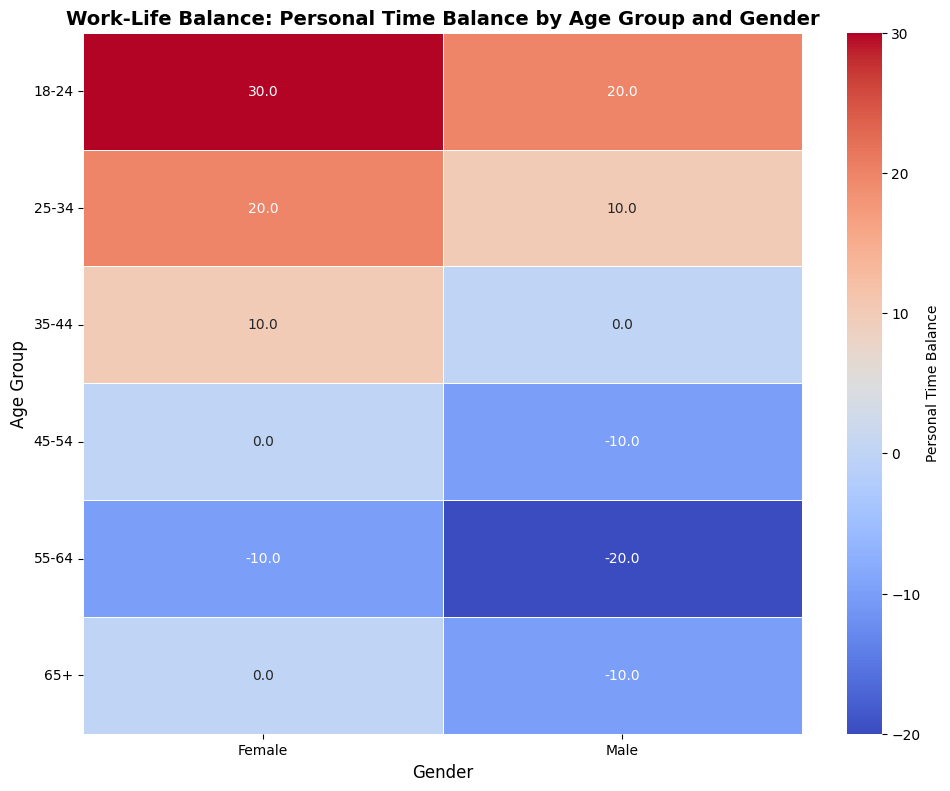What is the personal time balance for the 18-24 age group for females? Locate the cell corresponding to the 18-24 age group and the female gender in the heatmap. Read the value.
Answer: 30.0 Which age group has the highest personal time balance for males? Compare all the cells corresponding to "Males" in the figure. The value in the cell with the highest number represents the highest personal time balance for males.
Answer: 18-24 Is the personal time balance for females in the 25-34 age group greater than that of males in the same age group? Locate the 25-34 age group cells for both females and males. Compare their personal time balances, which are 20.0 for females and 15.0 for males.
Answer: Yes Which gender has a higher personal time balance in the 55-64 age group? Compare the cells for "Females" and "Males" in the 55-64 age group. The values are -10.0 for females and -20.0 for males.
Answer: Female Are there any age groups where both male and female truck drivers have an equal personal time balance? Examine each age group to see if there are corresponding values for males and females that are equal. The 65+ age group has a personal time balance of 0.0 for both genders.
Answer: Yes What is the overall trend in personal time balance as age increases for females? Observe the change in the personal time balance for the female column from the 18-24 age group to the 65+ age group. The values go from 30.0, 20.0, 10.0, 0.0, -10.0, to 0.0, indicating a decreasing trend up to 55-64, followed by an increase.
Answer: Decreasing then increases Which age group shows the most significant difference in personal time balance between genders, and what is that difference? Calculate the differences between male and female values for each age group. The largest difference is between the 55-64 age group: -10.0 for females and -20.0 for males, resulting in a difference of 10.0.
Answer: 55-64, 10.0 What color represents the highest personal time balance value in the heatmap? Look for the color that corresponds to the highest value (30.0), which is usually represented by the warmest color in a coolwarm color scheme. Based on the color scheme, it’s likely a shade of red or pink.
Answer: Red/Pink 